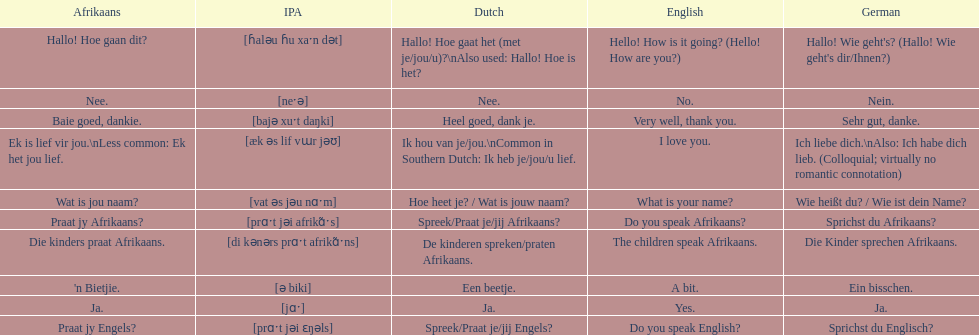How do you say 'yes' in afrikaans? Ja. 